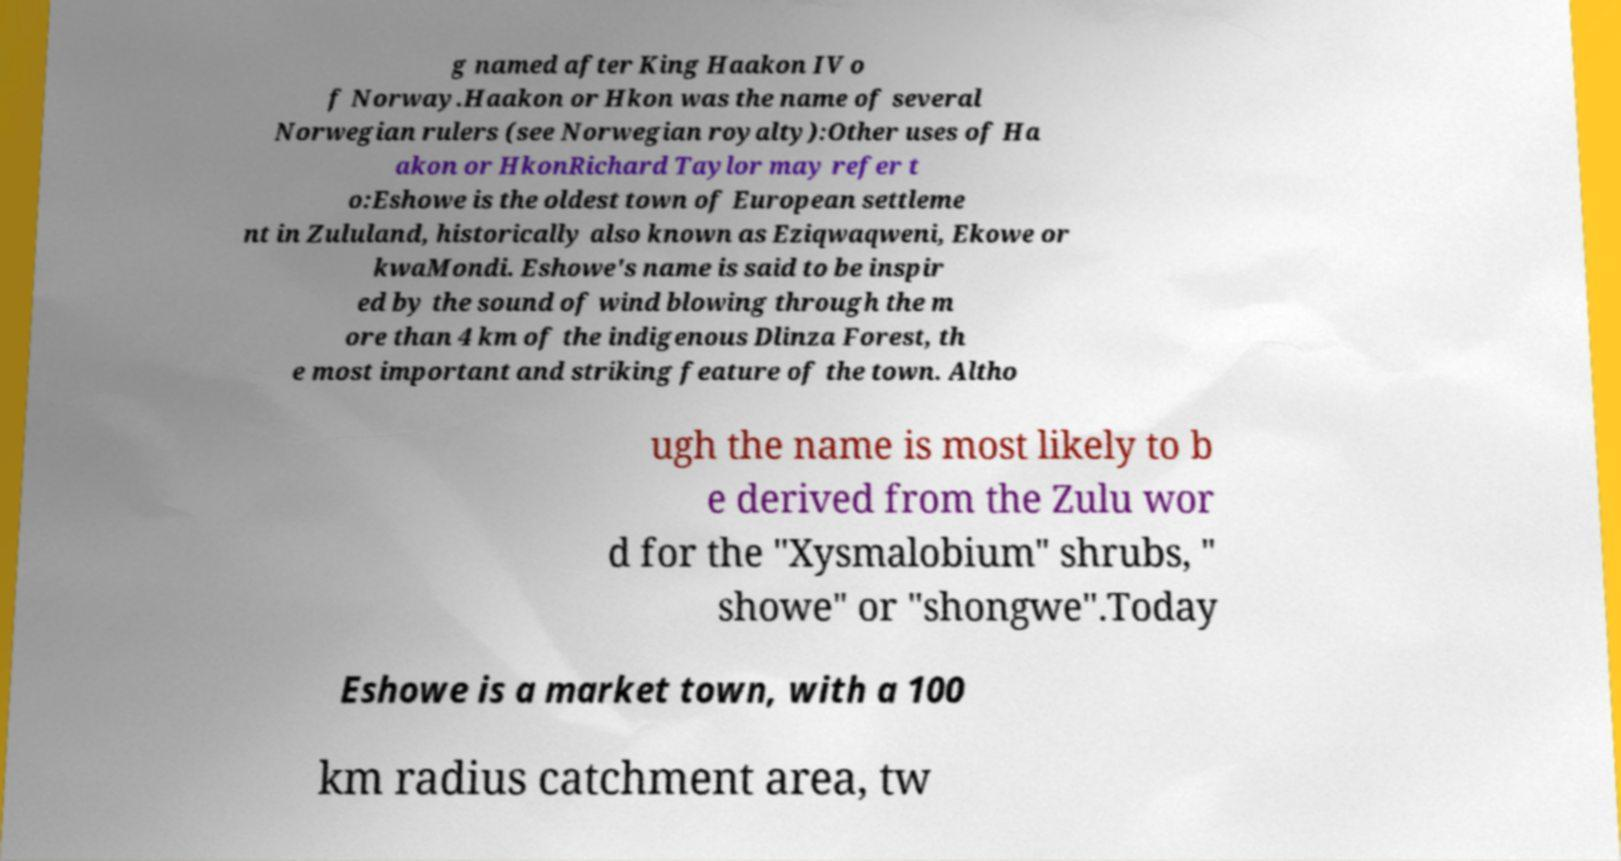Could you assist in decoding the text presented in this image and type it out clearly? g named after King Haakon IV o f Norway.Haakon or Hkon was the name of several Norwegian rulers (see Norwegian royalty):Other uses of Ha akon or HkonRichard Taylor may refer t o:Eshowe is the oldest town of European settleme nt in Zululand, historically also known as Eziqwaqweni, Ekowe or kwaMondi. Eshowe's name is said to be inspir ed by the sound of wind blowing through the m ore than 4 km of the indigenous Dlinza Forest, th e most important and striking feature of the town. Altho ugh the name is most likely to b e derived from the Zulu wor d for the "Xysmalobium" shrubs, " showe" or "shongwe".Today Eshowe is a market town, with a 100 km radius catchment area, tw 